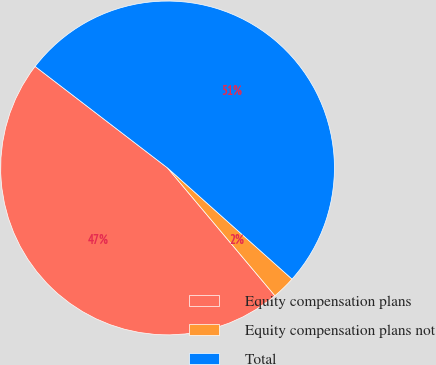Convert chart to OTSL. <chart><loc_0><loc_0><loc_500><loc_500><pie_chart><fcel>Equity compensation plans<fcel>Equity compensation plans not<fcel>Total<nl><fcel>46.53%<fcel>2.28%<fcel>51.19%<nl></chart> 